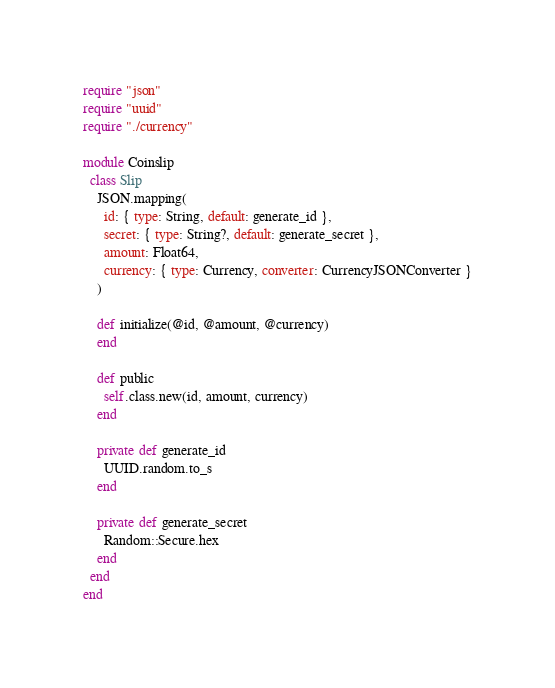Convert code to text. <code><loc_0><loc_0><loc_500><loc_500><_Crystal_>require "json"
require "uuid"
require "./currency"

module Coinslip
  class Slip
    JSON.mapping(
      id: { type: String, default: generate_id },
      secret: { type: String?, default: generate_secret },
      amount: Float64,
      currency: { type: Currency, converter: CurrencyJSONConverter }
    )

    def initialize(@id, @amount, @currency)
    end

    def public
      self.class.new(id, amount, currency)
    end

    private def generate_id
      UUID.random.to_s
    end

    private def generate_secret
      Random::Secure.hex
    end
  end
end
</code> 